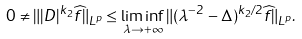Convert formula to latex. <formula><loc_0><loc_0><loc_500><loc_500>0 \not = \| | D | ^ { k _ { 2 } } \widehat { f } \| _ { L ^ { p } } \leq \liminf _ { \lambda \to + \infty } \| ( \lambda ^ { - 2 } - \Delta ) ^ { k _ { 2 } / 2 } \widehat { f } \| _ { L ^ { p } } .</formula> 